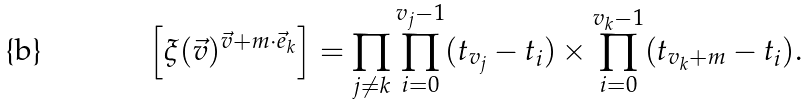<formula> <loc_0><loc_0><loc_500><loc_500>\left [ \xi ( \vec { v } ) ^ { \vec { v } + m \cdot \vec { e } _ { k } } \right ] = \prod _ { j \neq k } \prod _ { i = 0 } ^ { v _ { j } - 1 } ( t _ { v _ { j } } - t _ { i } ) \times \prod _ { i = 0 } ^ { v _ { k } - 1 } ( t _ { v _ { k } + m } - t _ { i } ) .</formula> 